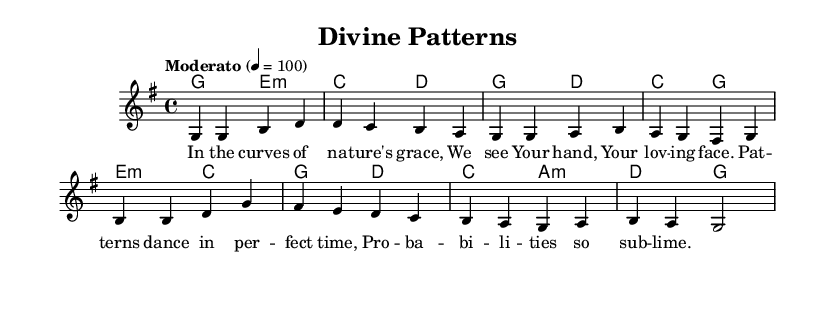What is the key signature of this music? The key signature is indicated at the beginning of the staff with one sharp (F#), which corresponds to the key of G major.
Answer: G major What is the time signature of this piece? The time signature is represented as a fraction at the beginning of the score, showing four beats per measure, which is 4/4.
Answer: 4/4 What is the tempo marking of this music? The tempo is marked “Moderato” followed by a metronome marking of quarter note equals 100, indicating a moderate speed.
Answer: Moderato How many measures are in the melody? Counting the lines and individual measure bars in the melody, there are a total of eight measures.
Answer: Eight What is the last chord in the harmony section? The last chord in the harmony is indicated with the letter ‘g’, which represents the G major chord.
Answer: G What theme is expressed in the lyrics? The lyrics convey a theme of divine presence in nature, highlighting the beauty and order found in natural patterns and probabilities.
Answer: Divine presence Which word in the lyrics emphasizes the connection to patterns? The word “patterns” in the line directly addresses the concept of repetitive forms and structures found in nature.
Answer: Patterns 